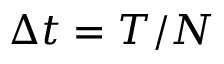<formula> <loc_0><loc_0><loc_500><loc_500>\Delta t = T / N</formula> 